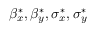Convert formula to latex. <formula><loc_0><loc_0><loc_500><loc_500>\beta _ { x } ^ { * } , \beta _ { y } ^ { * } , \sigma _ { x } ^ { * } , \sigma _ { y } ^ { * }</formula> 